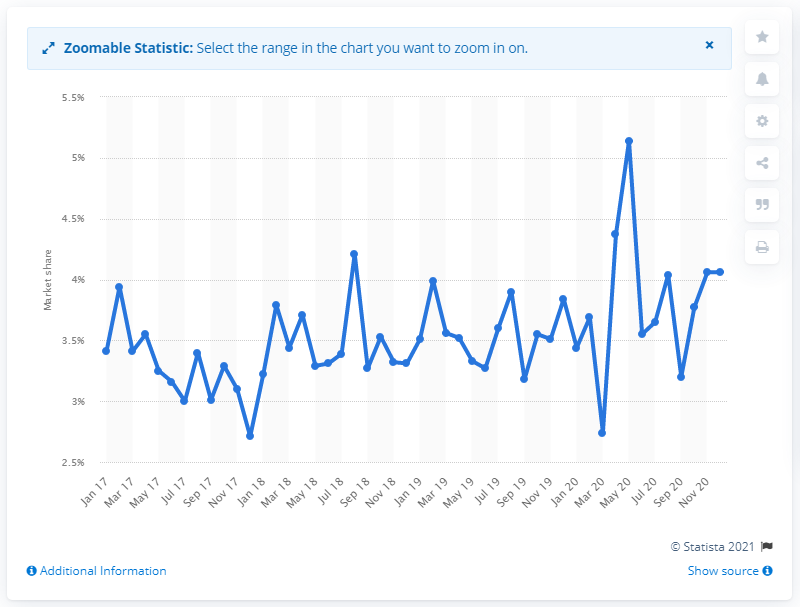Mention a couple of crucial points in this snapshot. According to data available in December 2020, Peugeot's market share was 4.06%. 